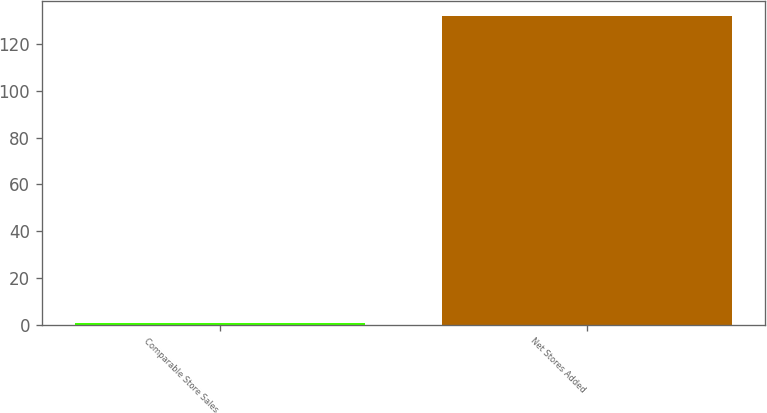<chart> <loc_0><loc_0><loc_500><loc_500><bar_chart><fcel>Comparable Store Sales<fcel>Net Stores Added<nl><fcel>0.8<fcel>132<nl></chart> 